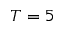Convert formula to latex. <formula><loc_0><loc_0><loc_500><loc_500>T = 5</formula> 